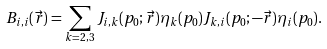Convert formula to latex. <formula><loc_0><loc_0><loc_500><loc_500>B _ { i , i } ( \vec { r } ) = \sum _ { k = 2 , 3 } J _ { i , k } ( p _ { 0 } ; \vec { r } ) \eta _ { k } ( p _ { 0 } ) J _ { k , i } ( p _ { 0 } ; - \vec { r } ) \eta _ { i } ( p _ { 0 } ) .</formula> 